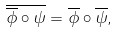Convert formula to latex. <formula><loc_0><loc_0><loc_500><loc_500>\overline { \overline { \phi } \circ \psi } = \overline { \phi } \circ \overline { \psi } ,</formula> 